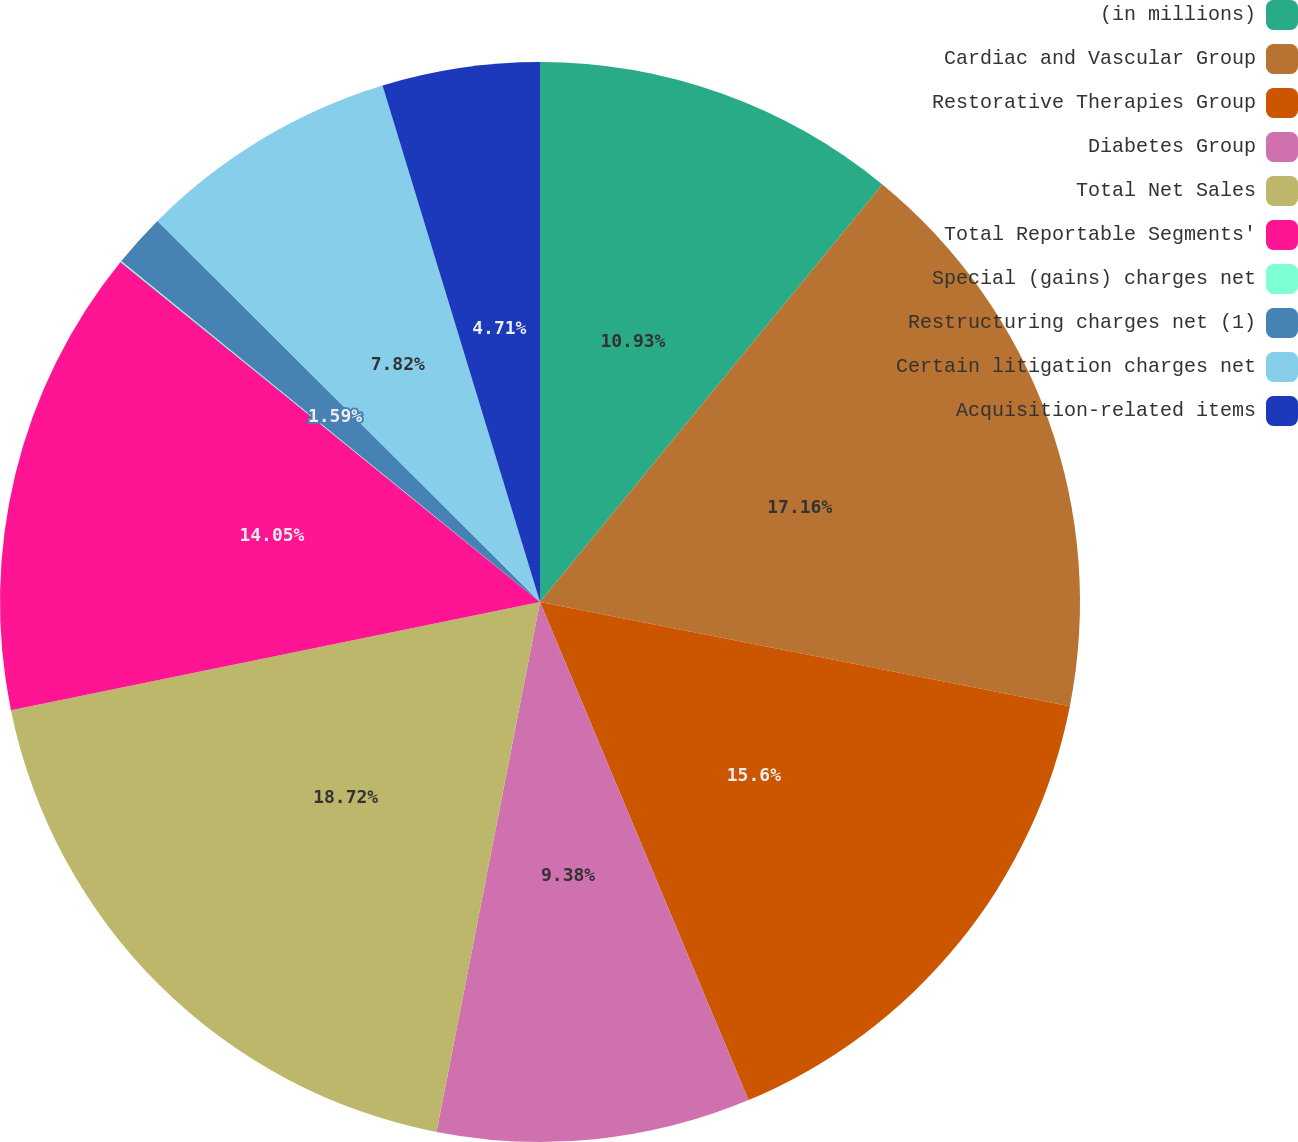<chart> <loc_0><loc_0><loc_500><loc_500><pie_chart><fcel>(in millions)<fcel>Cardiac and Vascular Group<fcel>Restorative Therapies Group<fcel>Diabetes Group<fcel>Total Net Sales<fcel>Total Reportable Segments'<fcel>Special (gains) charges net<fcel>Restructuring charges net (1)<fcel>Certain litigation charges net<fcel>Acquisition-related items<nl><fcel>10.93%<fcel>17.16%<fcel>15.6%<fcel>9.38%<fcel>18.72%<fcel>14.05%<fcel>0.04%<fcel>1.59%<fcel>7.82%<fcel>4.71%<nl></chart> 